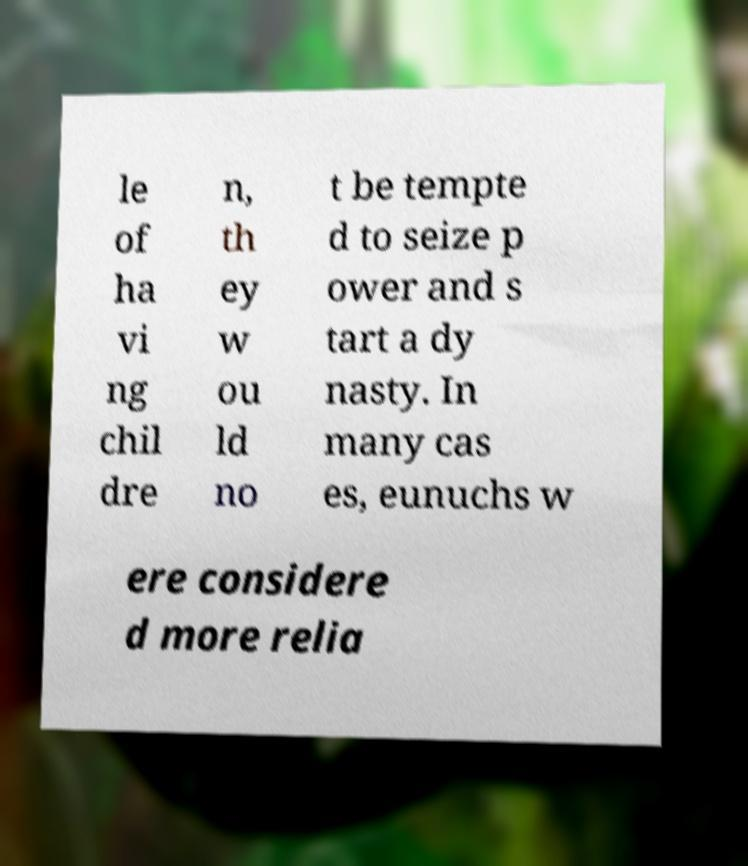There's text embedded in this image that I need extracted. Can you transcribe it verbatim? le of ha vi ng chil dre n, th ey w ou ld no t be tempte d to seize p ower and s tart a dy nasty. In many cas es, eunuchs w ere considere d more relia 